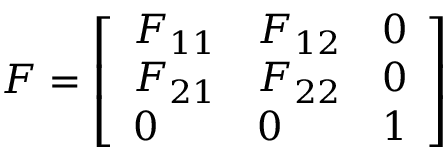<formula> <loc_0><loc_0><loc_500><loc_500>{ F } = { \left [ \begin{array} { l l l } { F _ { 1 1 } } & { F _ { 1 2 } } & { 0 } \\ { F _ { 2 1 } } & { F _ { 2 2 } } & { 0 } \\ { 0 } & { 0 } & { 1 } \end{array} \right ] }</formula> 